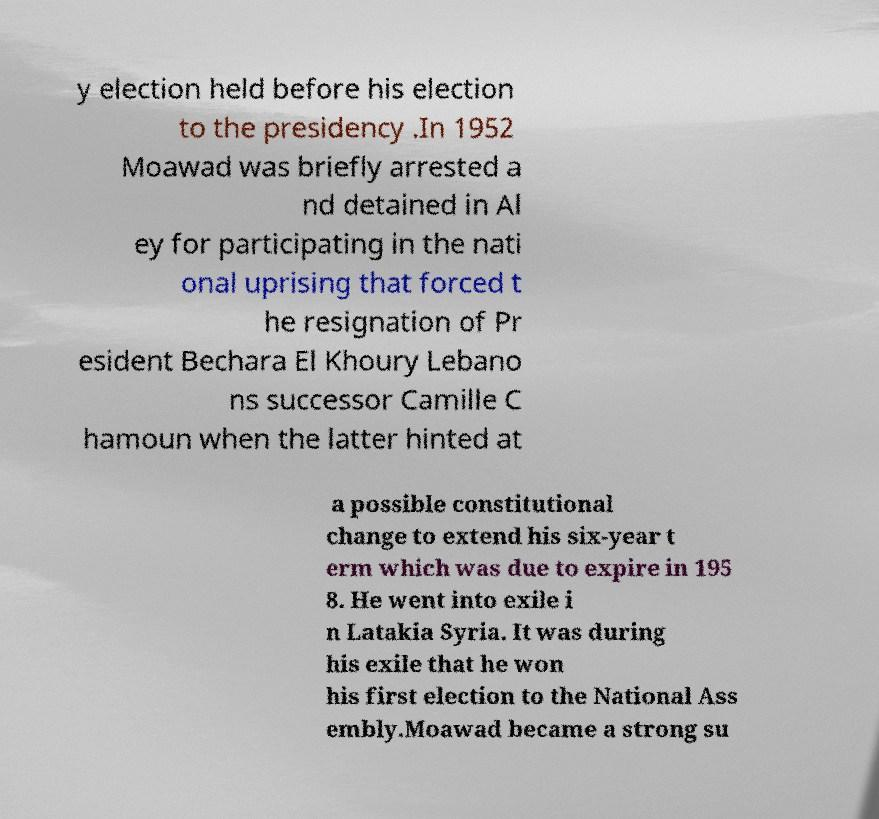Please read and relay the text visible in this image. What does it say? y election held before his election to the presidency .In 1952 Moawad was briefly arrested a nd detained in Al ey for participating in the nati onal uprising that forced t he resignation of Pr esident Bechara El Khoury Lebano ns successor Camille C hamoun when the latter hinted at a possible constitutional change to extend his six-year t erm which was due to expire in 195 8. He went into exile i n Latakia Syria. It was during his exile that he won his first election to the National Ass embly.Moawad became a strong su 